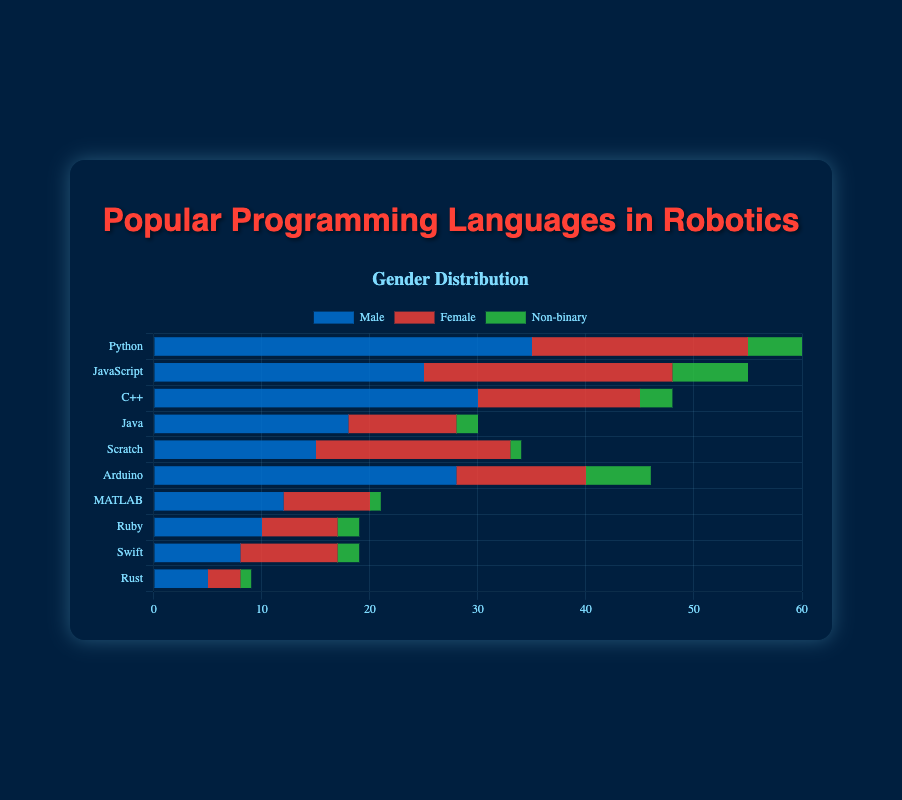What is the most popular programming language among male robotics enthusiasts? To find the most popular programming language among male robotics enthusiasts, look at the bar sections labeled "Male" and find the longest one. The longest bar for males corresponds to Python.
Answer: Python Which programming language do females prefer the most? Look at the sections of the bars labeled "Female" and identify which has the largest length. The largest section for females is for JavaScript.
Answer: JavaScript How many total enthusiasts (male, female, and non-binary) prefer Python? Sum the values for Python across males, females, and non-binary enthusiasts: 35 (male) + 20 (female) + 5 (non-binary) = 60.
Answer: 60 What is the difference in the number of male and female enthusiasts who prefer Arduino? Substract the number of females from the number of males who prefer Arduino: 28 (male) - 12 (female) = 16.
Answer: 16 Compare the popularity of Rust between male and female enthusiasts. Compare the lengths of the sections representing males and females for Rust. Rust is more popular among males (5) than females (3).
Answer: Rust is more popular among males Which gender has the least number of enthusiasts for Scratch? Look for the smallest section for Scratch among males, females, and non-binary enthusiasts. Non-binary has the least enthusiasts for Scratch with a value of 1.
Answer: Non-binary How does the popularity of C++ compare between males and non-binary enthusiasts? Compare the lengths of the sections representing males and non-binary enthusiasts for C++. C++ is more popular among males (30) compared to non-binary enthusiasts (3).
Answer: More popular among males Which programming language has the most balanced gender distribution? To find the most balanced gender distribution, check for the smallest differences between the lengths of the sections for males, females, and non-binary for each programming language. Scratch has the most balanced gender distribution, with males (15), females (18), and non-binary (1).
Answer: Scratch How many more male enthusiasts are there for MATLAB compared to Ruby? Subtract the number of males who prefer Ruby from those who prefer MATLAB: 12 (MATLAB) - 10 (Ruby) = 2.
Answer: 2 